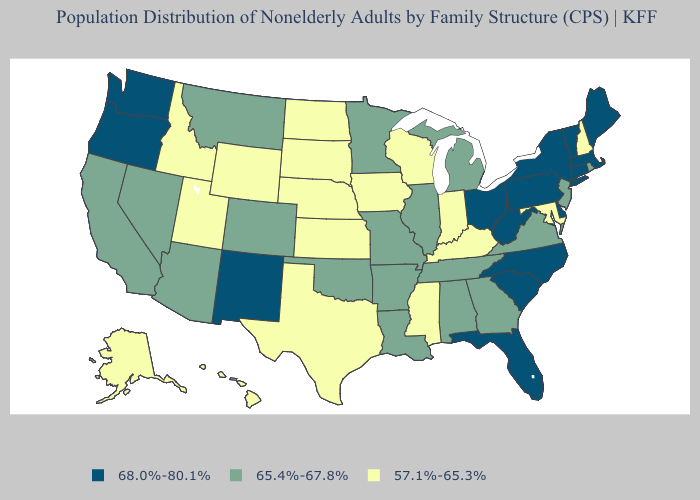What is the value of Colorado?
Concise answer only. 65.4%-67.8%. What is the highest value in states that border Mississippi?
Give a very brief answer. 65.4%-67.8%. What is the value of South Carolina?
Quick response, please. 68.0%-80.1%. Among the states that border Maryland , does West Virginia have the highest value?
Short answer required. Yes. What is the highest value in states that border New Jersey?
Give a very brief answer. 68.0%-80.1%. What is the highest value in the USA?
Keep it brief. 68.0%-80.1%. Among the states that border Kentucky , does Indiana have the lowest value?
Answer briefly. Yes. What is the value of Kentucky?
Answer briefly. 57.1%-65.3%. Does Hawaii have the same value as New Jersey?
Quick response, please. No. What is the value of Minnesota?
Give a very brief answer. 65.4%-67.8%. Does Wyoming have a lower value than Texas?
Concise answer only. No. What is the lowest value in the South?
Quick response, please. 57.1%-65.3%. How many symbols are there in the legend?
Short answer required. 3. Name the states that have a value in the range 65.4%-67.8%?
Concise answer only. Alabama, Arizona, Arkansas, California, Colorado, Georgia, Illinois, Louisiana, Michigan, Minnesota, Missouri, Montana, Nevada, New Jersey, Oklahoma, Rhode Island, Tennessee, Virginia. 